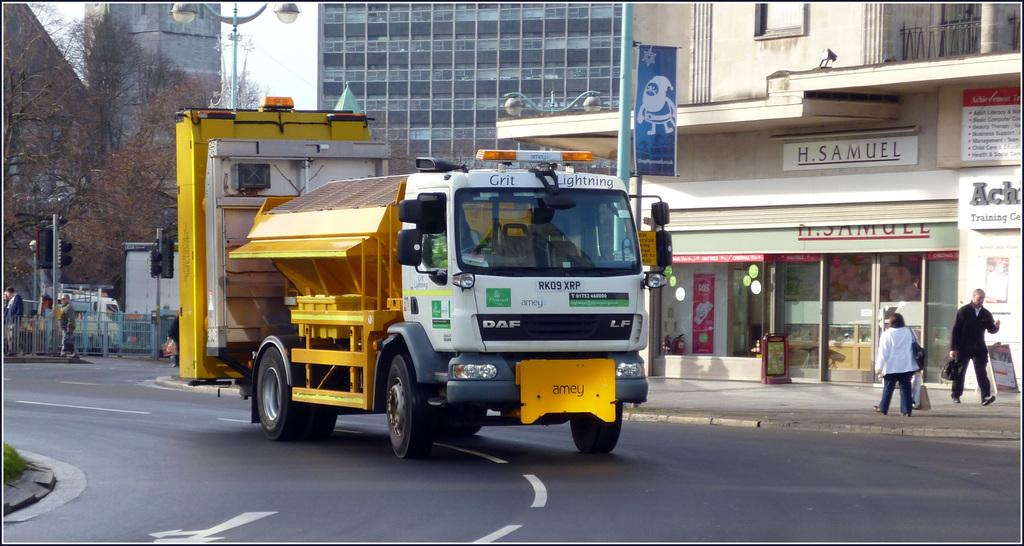What type of vehicle is on the road in the image? There is a truck on the road in the image. What structures can be seen in the image? There are buildings in the image. What type of vegetation is present in the image? There are trees in the image. What traffic control devices are visible in the image? There are traffic lights in the image. What other poles can be seen in the image? There are other poles in the image. What activity are people engaged in on the pavement in the image? There are people walking on the pavement in the image. What type of paste is being used to fix the veins in the image? There is no paste or veins present in the image; it features a truck on the road, buildings, trees, traffic lights, poles, and people walking on the pavement. 